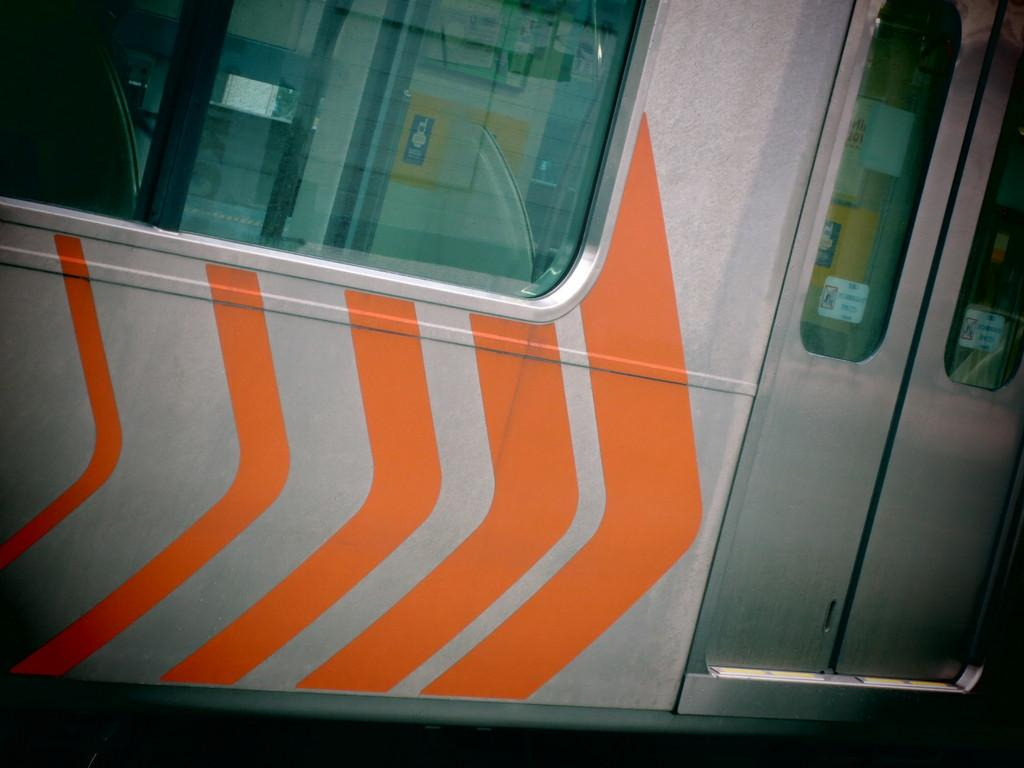What type of doors are visible in the image? There are metal doors in the image. What type of window can be seen in the image? The window in the image resembles that of a metro train. How many stars can be seen on the chair in the image? There is no chair or star present in the image. What type of shake is being offered in the image? There is no shake present in the image. 